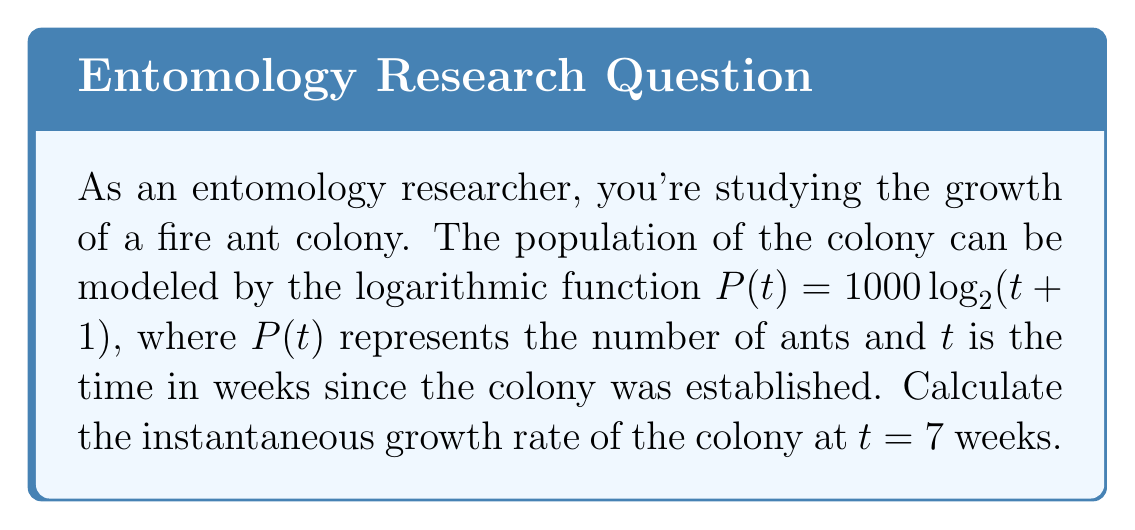Could you help me with this problem? To find the instantaneous growth rate at $t = 7$ weeks, we need to calculate the derivative of the population function $P(t)$ and evaluate it at $t = 7$.

1) First, let's rewrite the function using the natural logarithm:
   $P(t) = 1000 \log_2(t+1) = \frac{1000}{\ln(2)} \ln(t+1)$

2) Now, let's calculate the derivative using the chain rule:
   $$\frac{dP}{dt} = \frac{1000}{\ln(2)} \cdot \frac{1}{t+1}$$

3) Evaluate the derivative at $t = 7$:
   $$\frac{dP}{dt}\bigg|_{t=7} = \frac{1000}{\ln(2)} \cdot \frac{1}{7+1} = \frac{1000}{\ln(2)} \cdot \frac{1}{8}$$

4) Simplify:
   $$\frac{dP}{dt}\bigg|_{t=7} = \frac{125}{\ln(2)} \approx 180.33$$

This result represents the instantaneous growth rate in ants per week at $t = 7$ weeks.
Answer: The instantaneous growth rate of the fire ant colony at $t = 7$ weeks is approximately 180.33 ants per week. 